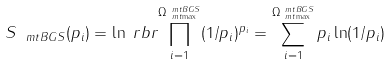Convert formula to latex. <formula><loc_0><loc_0><loc_500><loc_500>S _ { \ m t { B G S } } ( p _ { i } ) & = \ln \ r b r { \prod _ { i = 1 } ^ { \Omega _ { \ m t { \max } } ^ { \ m t { B G S } } } ( 1 / p _ { i } ) ^ { p _ { i } } } = \sum _ { i = 1 } ^ { \Omega _ { \ m t { \max } } ^ { \ m t { B G S } } } p _ { i } \ln ( 1 / p _ { i } )</formula> 